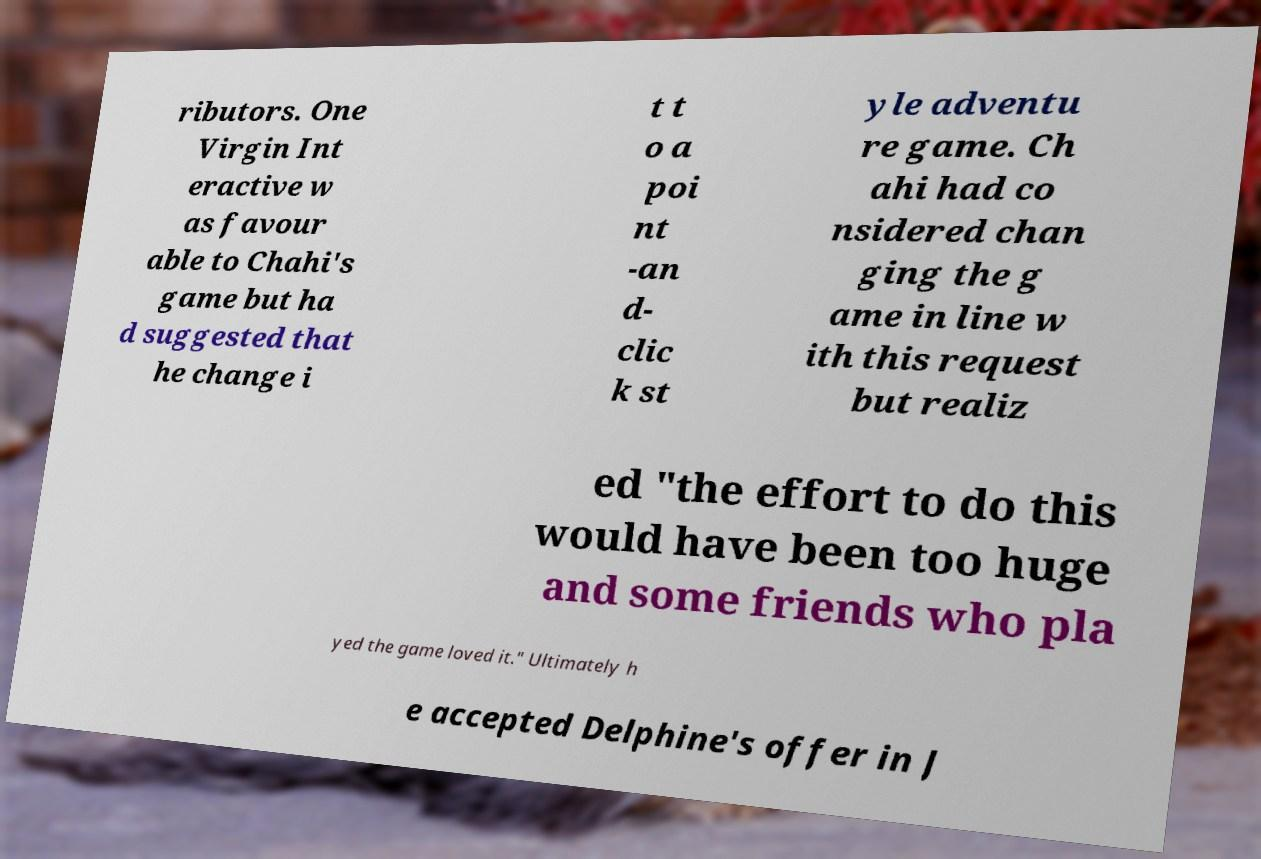There's text embedded in this image that I need extracted. Can you transcribe it verbatim? ributors. One Virgin Int eractive w as favour able to Chahi's game but ha d suggested that he change i t t o a poi nt -an d- clic k st yle adventu re game. Ch ahi had co nsidered chan ging the g ame in line w ith this request but realiz ed "the effort to do this would have been too huge and some friends who pla yed the game loved it." Ultimately h e accepted Delphine's offer in J 